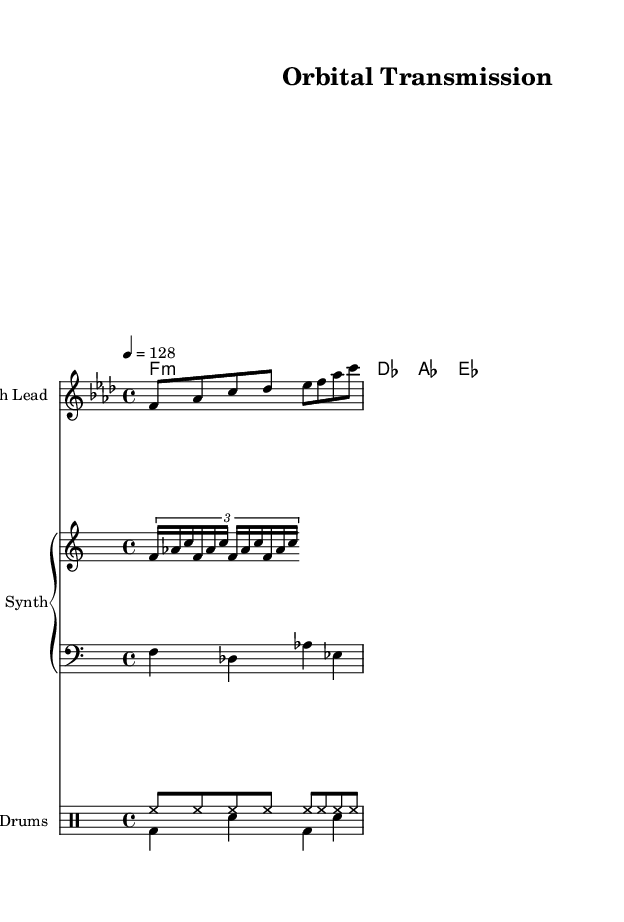What is the key signature of this music? The key signature is F minor, indicated by the presence of four flats (B♭, E♭, A♭, D♭). This can be determined from the global setup in the sheet music.
Answer: F minor What is the time signature? The time signature is 4/4, which is represented at the beginning of the global section of the sheet music. This means there are four beats in each measure and a quarter note receives one beat.
Answer: 4/4 What is the tempo marking in beats per minute? The tempo marking shown is 128 beats per minute, which can be found in the global section indicated by "4 = 128". This indicates the speed of the music.
Answer: 128 What instrument is specified for the melody? The melody is written for "Synth Lead," as indicated at the beginning of the staff for the melody. This informs players what instrument will perform that line.
Answer: Synth Lead How many beats does the bass line have per measure? The bass line in this piece has four beats per measure, as indicated by the quarter note duration of the notes and the 4/4 time signature, meaning each measure is filled with quarters totaling four beats.
Answer: 4 Which type of drum is played on the upbeats? The drum pattern on the upbeats consists of closed hi-hat (hh) hits, as represented in the drumPatternUp section of the music with continuous eighth-note occurrences throughout.
Answer: Closed Hi-hat What type of chord progression is present in harmony? The chord progression is a minor progression, consisting of F minor, D♭ major, A♭ major, and E♭ major chords, which follows common house music structures. This can be derived from the chordmode section where these chords are listed.
Answer: Minor progression 